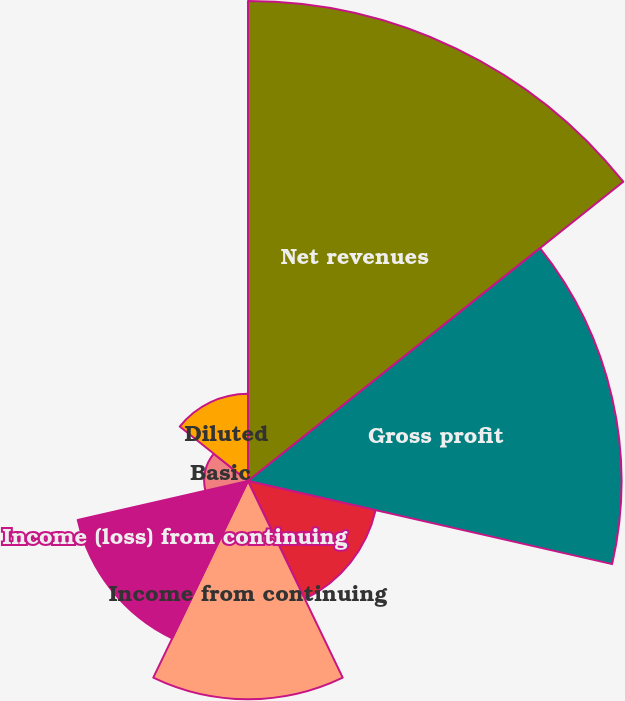Convert chart to OTSL. <chart><loc_0><loc_0><loc_500><loc_500><pie_chart><fcel>Net revenues<fcel>Gross profit<fcel>Income from operations<fcel>Income from continuing<fcel>Income (loss) from continuing<fcel>Basic<fcel>Diluted<nl><fcel>31.82%<fcel>24.76%<fcel>8.68%<fcel>14.47%<fcel>11.58%<fcel>2.9%<fcel>5.79%<nl></chart> 